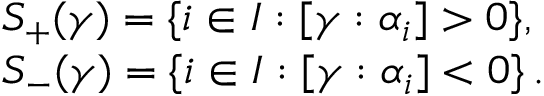<formula> <loc_0><loc_0><loc_500><loc_500>\begin{array} { l } { { S _ { + } ( \gamma ) = \{ i \in I \colon [ \gamma \colon \alpha _ { i } ] > 0 \} , } } \\ { { S _ { - } ( \gamma ) = \{ i \in I \colon [ \gamma \colon \alpha _ { i } ] < 0 \} \, . } } \end{array}</formula> 